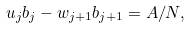<formula> <loc_0><loc_0><loc_500><loc_500>u _ { j } b _ { j } - w _ { j + 1 } b _ { j + 1 } = A / N ,</formula> 